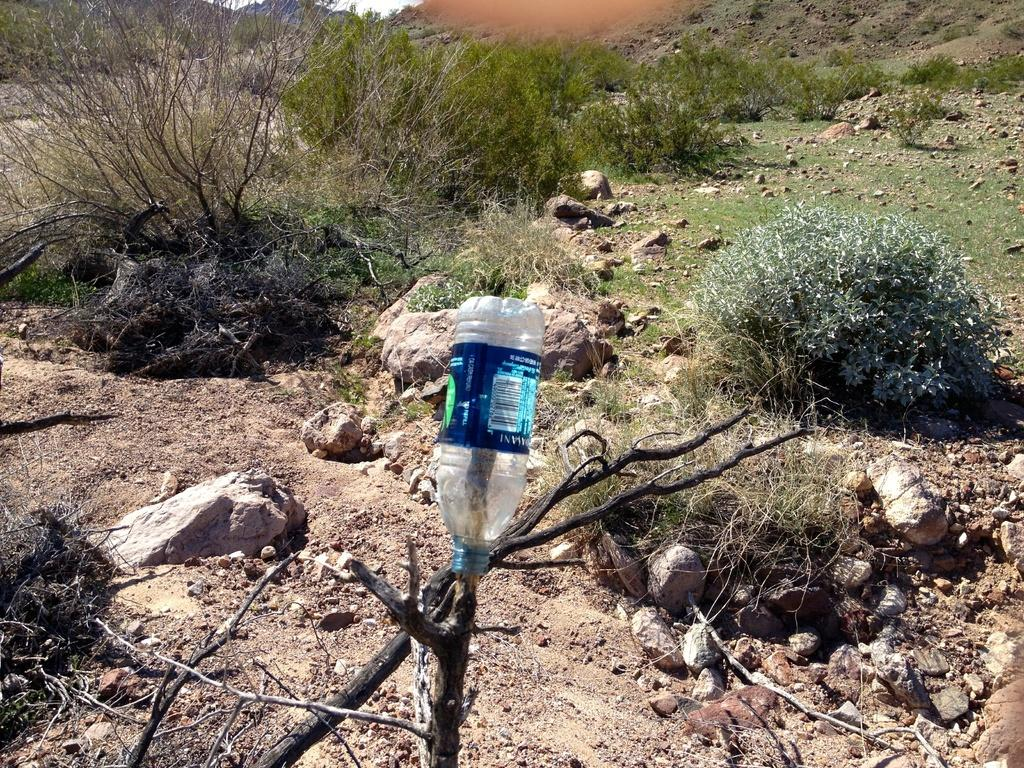What type of vegetation can be seen in the image? There are plants in the image. What part of the natural environment is visible in the image? The sky is visible in the image. What type of ground cover can be seen in the image? There is dry grass in the image. What other objects are present in the image? There are twigs, a bottle on the twigs, rocks, mud, and stones in the image. How many times does the dinosaur sneeze in the image? There are no dinosaurs present in the image, so it is not possible to determine how many times a dinosaur sneezes. 